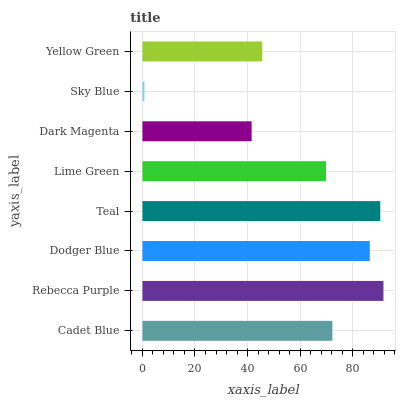Is Sky Blue the minimum?
Answer yes or no. Yes. Is Rebecca Purple the maximum?
Answer yes or no. Yes. Is Dodger Blue the minimum?
Answer yes or no. No. Is Dodger Blue the maximum?
Answer yes or no. No. Is Rebecca Purple greater than Dodger Blue?
Answer yes or no. Yes. Is Dodger Blue less than Rebecca Purple?
Answer yes or no. Yes. Is Dodger Blue greater than Rebecca Purple?
Answer yes or no. No. Is Rebecca Purple less than Dodger Blue?
Answer yes or no. No. Is Cadet Blue the high median?
Answer yes or no. Yes. Is Lime Green the low median?
Answer yes or no. Yes. Is Teal the high median?
Answer yes or no. No. Is Dodger Blue the low median?
Answer yes or no. No. 